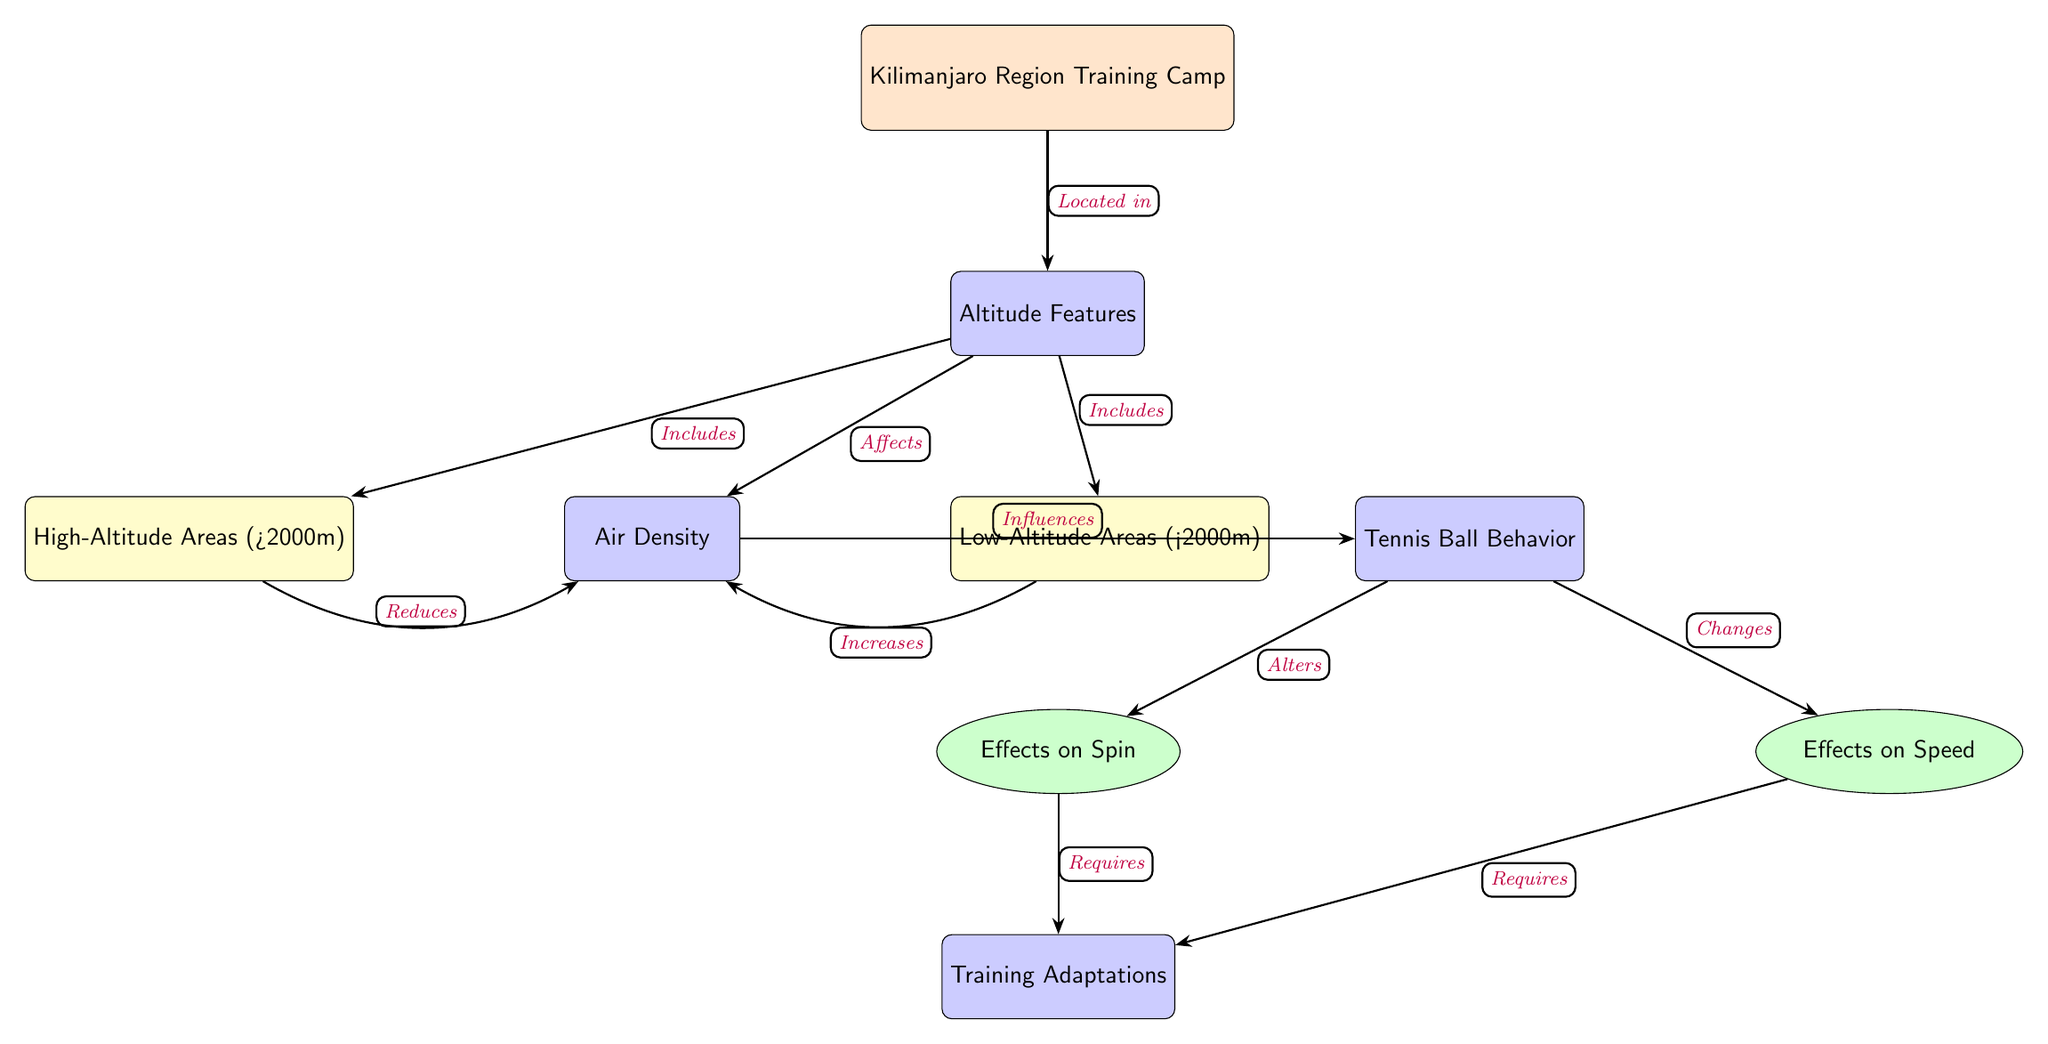What is the main focus of the diagram? The diagram’s main theme is denoted at the top node labeled "Kilimanjaro Region Training Camp," which indicates the broader context for the relationships illustrated below it.
Answer: Kilimanjaro Region Training Camp How many altitude categories are shown? There are two altitude categories illustrated in the diagram: "High-Altitude Areas (>2000m)" and "Low-Altitude Areas (<2000m)". This can be counted as there are two nodes directly linked to the "Altitude Features" node.
Answer: 2 What effect does high altitude have on air density? The diagram indicates that the effect of high altitude is represented with an arrow labeled "Reduces" going from "High-Altitude Areas (>2000m)" to "Air Density," suggesting a decrease in air density at high altitudes.
Answer: Reduces What influences tennis ball behavior according to the diagram? The connection between "Air Density" and "Tennis Ball Behavior," as represented in the diagram, shows that air density is a crucial factor that influences how the tennis ball behaves during play.
Answer: Air Density What adaptations are required due to changes in spin and speed? The diagram shows that both "Effects on Spin" and "Effects on Speed" lead to the same node labeled "Training Adaptations," indicating that adaptations in training are needed to address these changes.
Answer: Training Adaptations Which altitude area increases air density? The diagram illustrates that "Low-Altitude Areas (<2000m)" have an arrow labeled "Increases" pointing towards "Air Density," indicating the effect of low altitude is an increase in air density.
Answer: Increases What relationship exists between altitude features and air density? The node labeled "Altitude Features" has a connection (labeled "Affects") leading to "Air Density," indicating that altitude features play a role in altering air density levels.
Answer: Affects How does tennis ball behavior affect training adaptations? The diagram shows arrows from "Tennis Ball Behavior" to "Training Adaptations," indicating that the behavior of the tennis ball influences the necessary adaptations in training.
Answer: Influences 